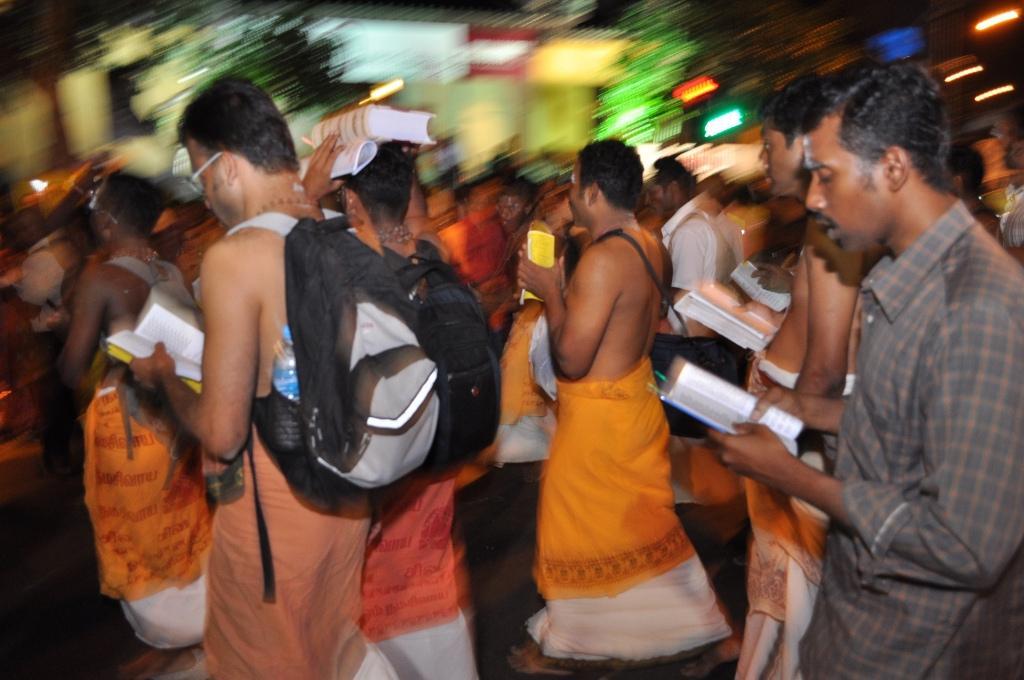Could you give a brief overview of what you see in this image? Here in this picture we can see number of people walking on the ground over there and we can see all of them are holding books in their hands and we can see some people are carrying bags with them. 